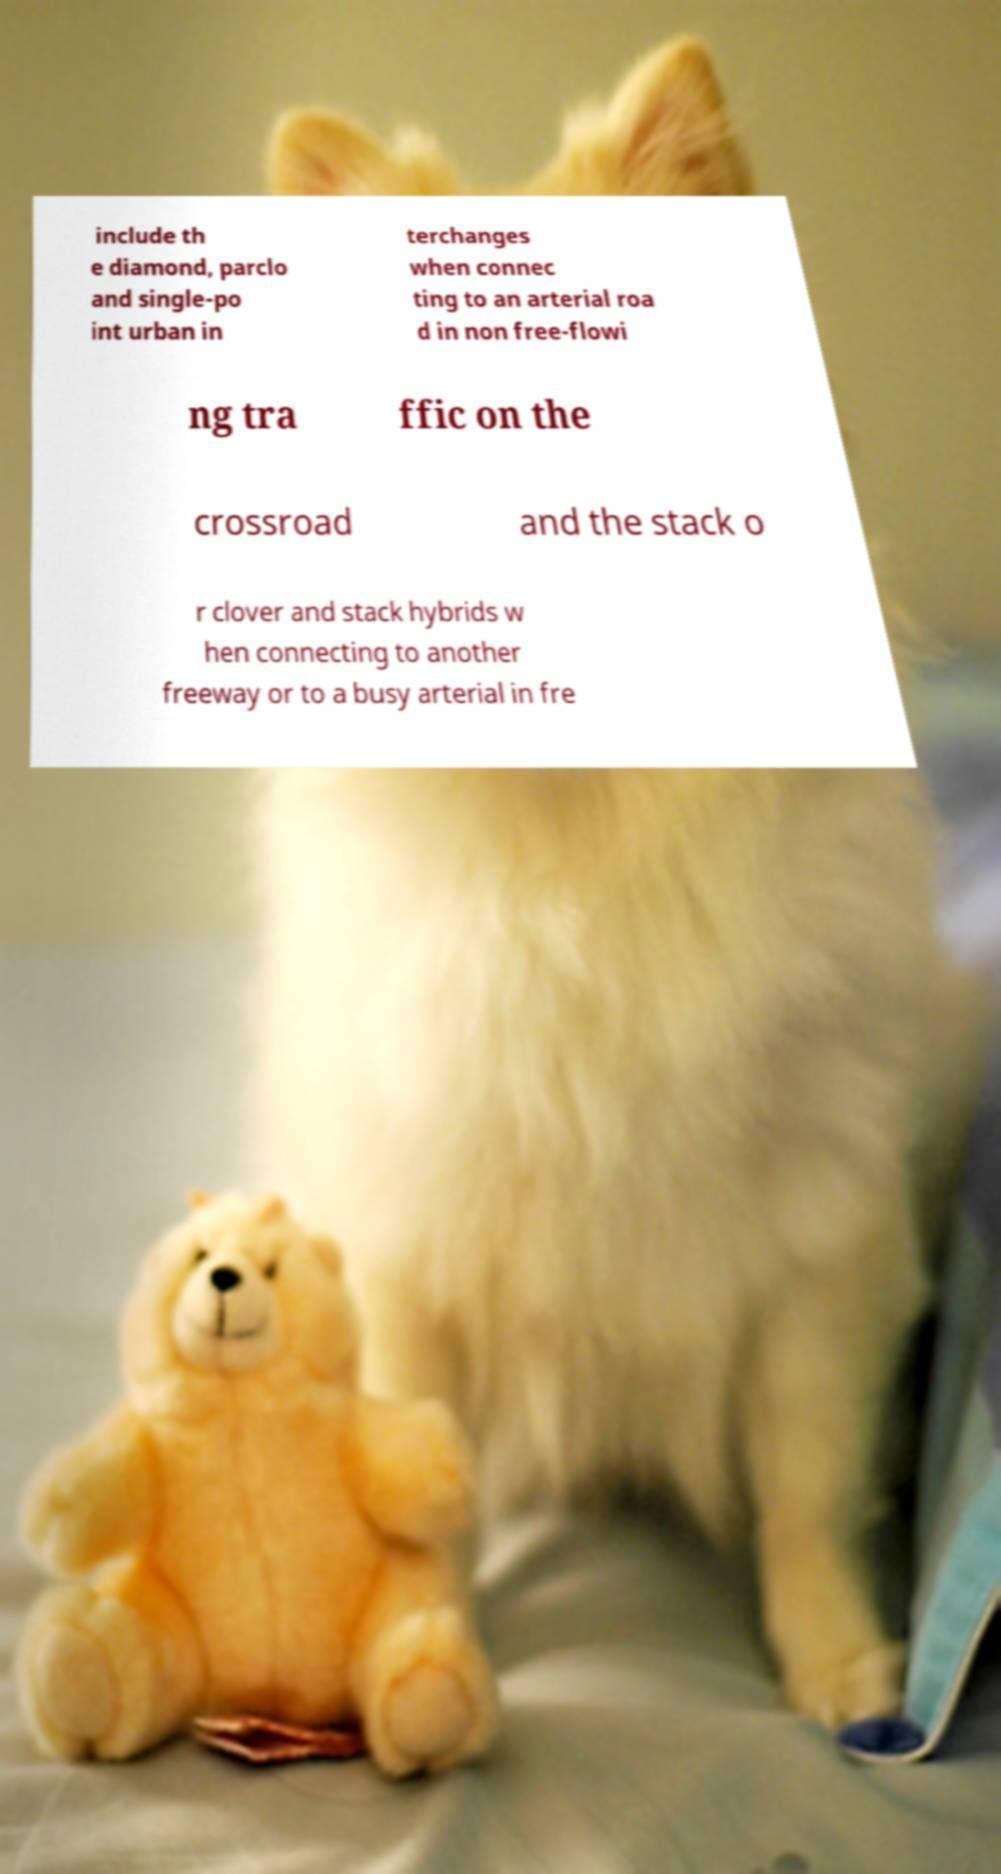Could you extract and type out the text from this image? include th e diamond, parclo and single-po int urban in terchanges when connec ting to an arterial roa d in non free-flowi ng tra ffic on the crossroad and the stack o r clover and stack hybrids w hen connecting to another freeway or to a busy arterial in fre 